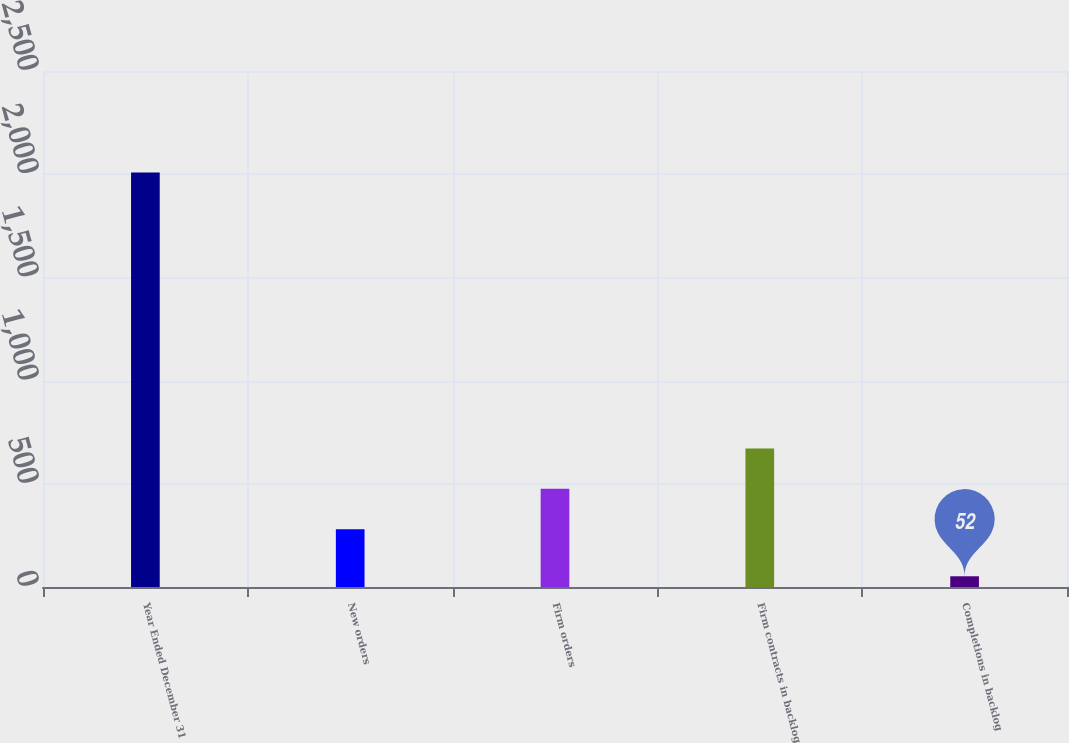<chart> <loc_0><loc_0><loc_500><loc_500><bar_chart><fcel>Year Ended December 31<fcel>New orders<fcel>Firm orders<fcel>Firm contracts in backlog<fcel>Completions in backlog<nl><fcel>2008<fcel>280<fcel>475.6<fcel>671.2<fcel>52<nl></chart> 